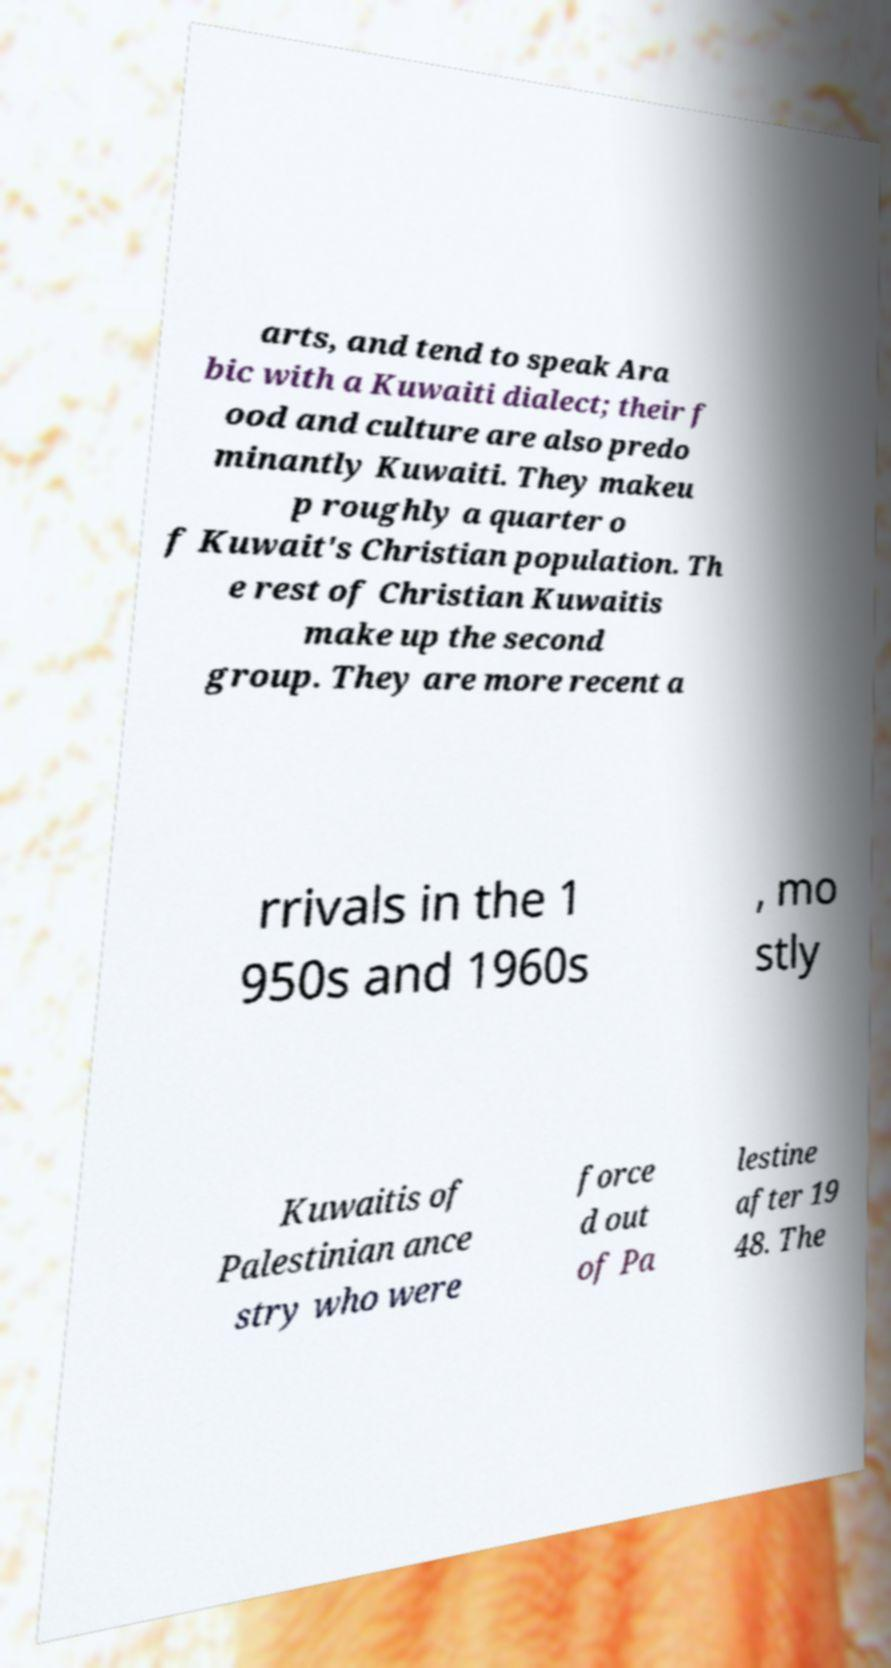Please read and relay the text visible in this image. What does it say? arts, and tend to speak Ara bic with a Kuwaiti dialect; their f ood and culture are also predo minantly Kuwaiti. They makeu p roughly a quarter o f Kuwait's Christian population. Th e rest of Christian Kuwaitis make up the second group. They are more recent a rrivals in the 1 950s and 1960s , mo stly Kuwaitis of Palestinian ance stry who were force d out of Pa lestine after 19 48. The 